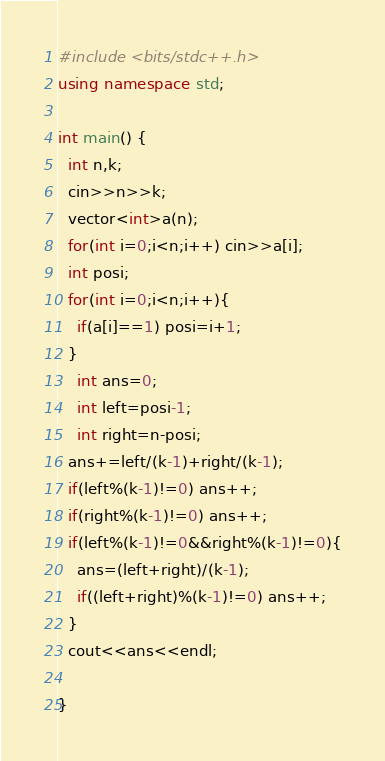Convert code to text. <code><loc_0><loc_0><loc_500><loc_500><_C++_>#include <bits/stdc++.h>
using namespace std;

int main() {
  int n,k;
  cin>>n>>k;
  vector<int>a(n);
  for(int i=0;i<n;i++) cin>>a[i];
  int posi;
  for(int i=0;i<n;i++){
    if(a[i]==1) posi=i+1;
  }
    int ans=0;
    int left=posi-1;
    int right=n-posi;
  ans+=left/(k-1)+right/(k-1);
  if(left%(k-1)!=0) ans++;
  if(right%(k-1)!=0) ans++;
  if(left%(k-1)!=0&&right%(k-1)!=0){
    ans=(left+right)/(k-1);
    if((left+right)%(k-1)!=0) ans++;
  }
  cout<<ans<<endl;
  
}

</code> 